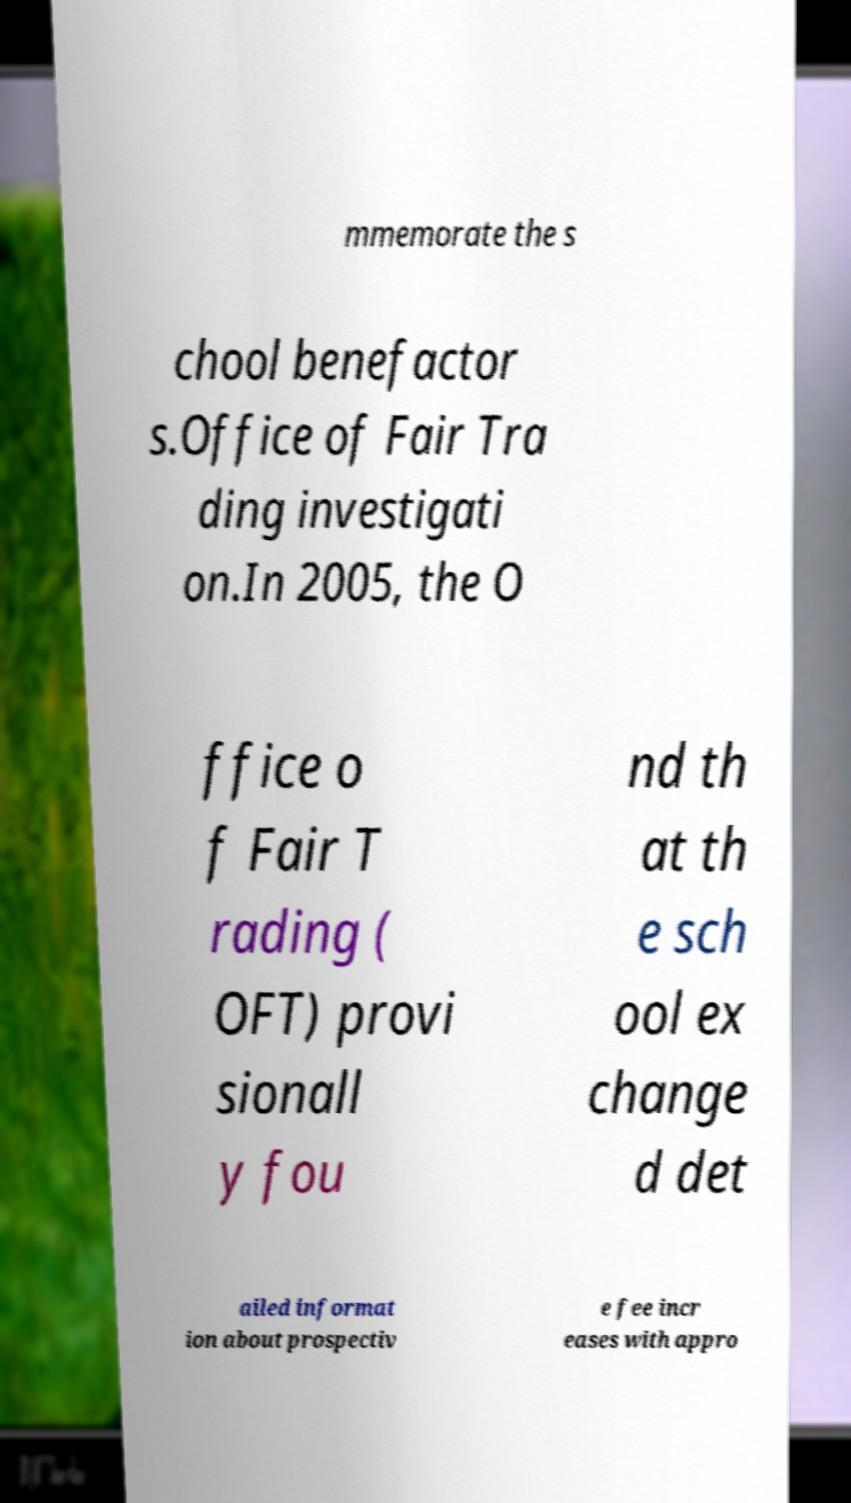Can you accurately transcribe the text from the provided image for me? mmemorate the s chool benefactor s.Office of Fair Tra ding investigati on.In 2005, the O ffice o f Fair T rading ( OFT) provi sionall y fou nd th at th e sch ool ex change d det ailed informat ion about prospectiv e fee incr eases with appro 